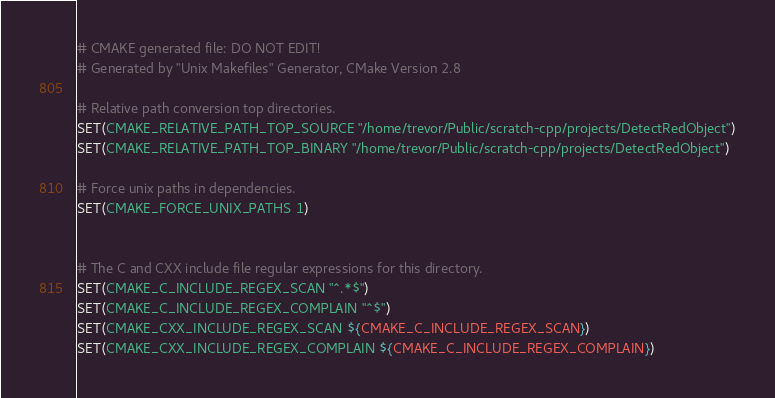Convert code to text. <code><loc_0><loc_0><loc_500><loc_500><_CMake_># CMAKE generated file: DO NOT EDIT!
# Generated by "Unix Makefiles" Generator, CMake Version 2.8

# Relative path conversion top directories.
SET(CMAKE_RELATIVE_PATH_TOP_SOURCE "/home/trevor/Public/scratch-cpp/projects/DetectRedObject")
SET(CMAKE_RELATIVE_PATH_TOP_BINARY "/home/trevor/Public/scratch-cpp/projects/DetectRedObject")

# Force unix paths in dependencies.
SET(CMAKE_FORCE_UNIX_PATHS 1)


# The C and CXX include file regular expressions for this directory.
SET(CMAKE_C_INCLUDE_REGEX_SCAN "^.*$")
SET(CMAKE_C_INCLUDE_REGEX_COMPLAIN "^$")
SET(CMAKE_CXX_INCLUDE_REGEX_SCAN ${CMAKE_C_INCLUDE_REGEX_SCAN})
SET(CMAKE_CXX_INCLUDE_REGEX_COMPLAIN ${CMAKE_C_INCLUDE_REGEX_COMPLAIN})
</code> 